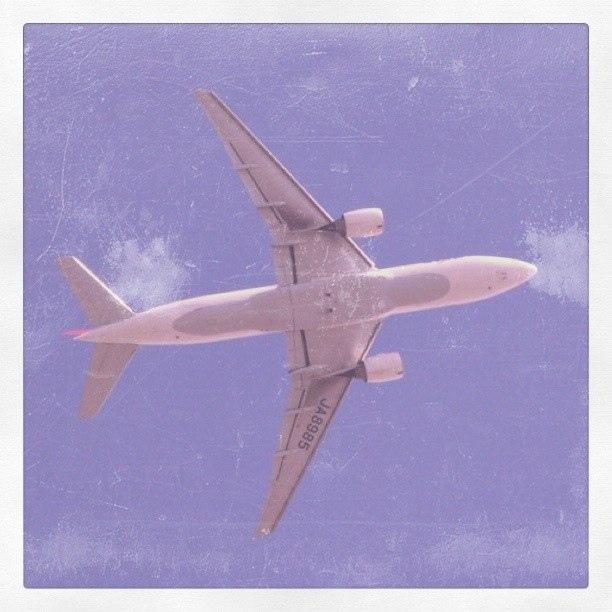What is the nomenclature depicted on the wing?
Be succinct. Ja8985. What color is the plane?
Short answer required. White. What perspective is the photo taken from?
Keep it brief. Below. 